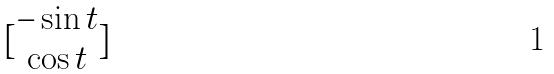<formula> <loc_0><loc_0><loc_500><loc_500>[ \begin{matrix} - \sin t \\ \cos t \end{matrix} ]</formula> 